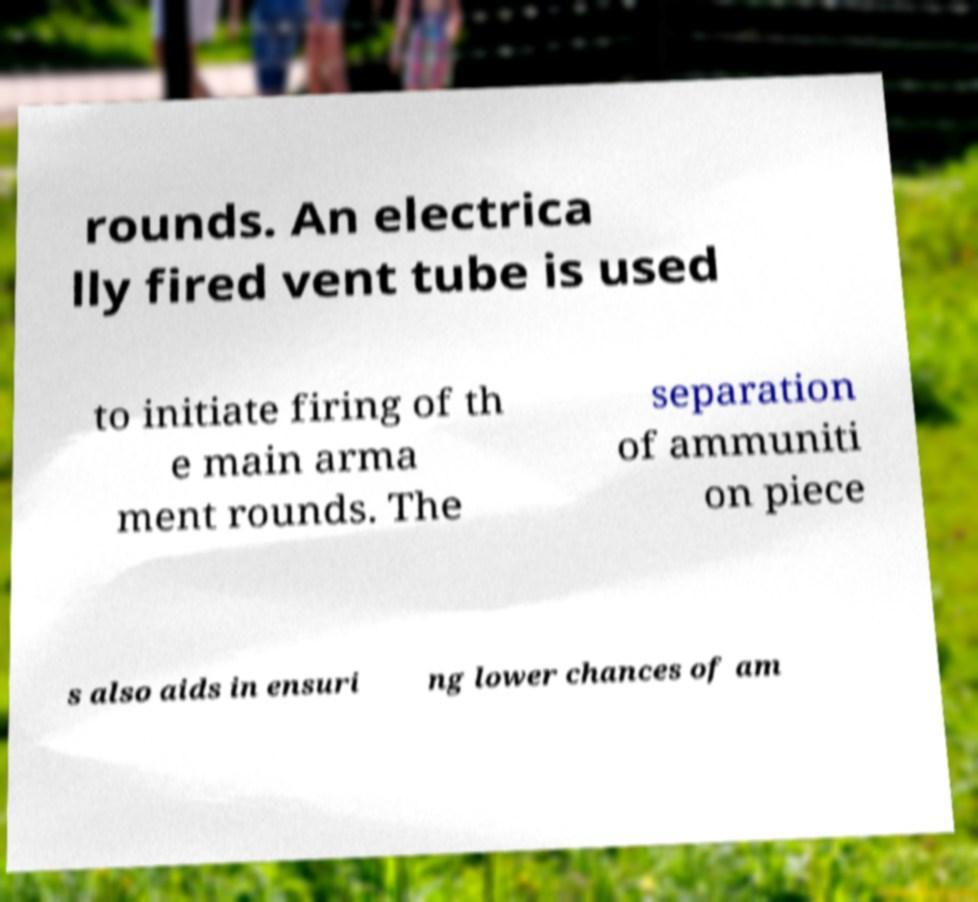Could you extract and type out the text from this image? rounds. An electrica lly fired vent tube is used to initiate firing of th e main arma ment rounds. The separation of ammuniti on piece s also aids in ensuri ng lower chances of am 